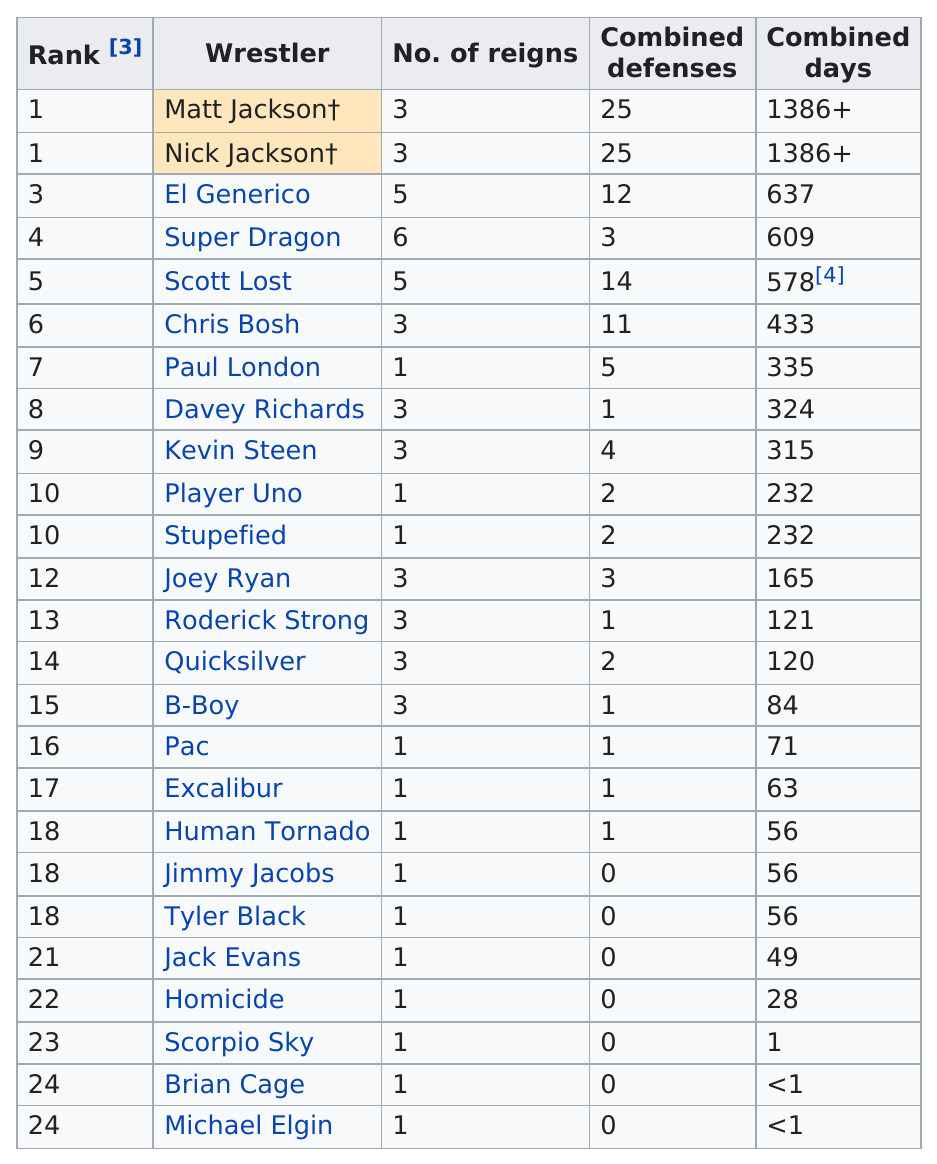Identify some key points in this picture. According to records, Scott Lost held the highest number of reigns and defenses, surpassing both Super Dragon and Paul London. Please provide more context or clarify your request. "How many wrestlers have at least 2 number of reigns?" is a grammatically correct sentence, but it is unclear what is being asked. Kevin Steen had a combined total of 315 days. Based on the chart provided, a total of 25 wrestlers are listed. With a unique distinction, Scorpio Sky is the only wrestler to have achieved a record of having only one combined day in all of his accomplishments. 